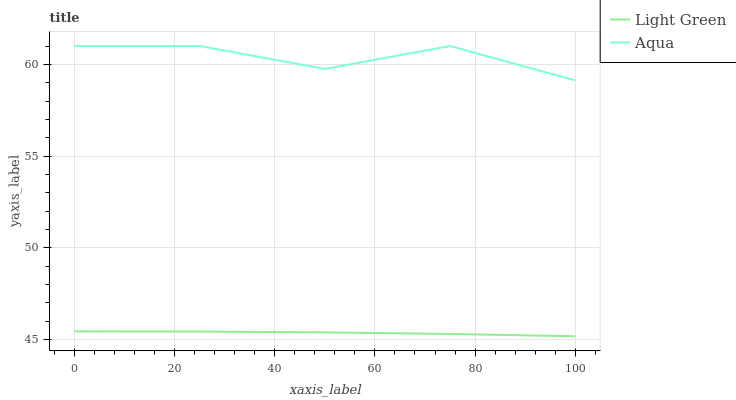Does Light Green have the minimum area under the curve?
Answer yes or no. Yes. Does Aqua have the maximum area under the curve?
Answer yes or no. Yes. Does Light Green have the maximum area under the curve?
Answer yes or no. No. Is Light Green the smoothest?
Answer yes or no. Yes. Is Aqua the roughest?
Answer yes or no. Yes. Is Light Green the roughest?
Answer yes or no. No. Does Light Green have the lowest value?
Answer yes or no. Yes. Does Aqua have the highest value?
Answer yes or no. Yes. Does Light Green have the highest value?
Answer yes or no. No. Is Light Green less than Aqua?
Answer yes or no. Yes. Is Aqua greater than Light Green?
Answer yes or no. Yes. Does Light Green intersect Aqua?
Answer yes or no. No. 